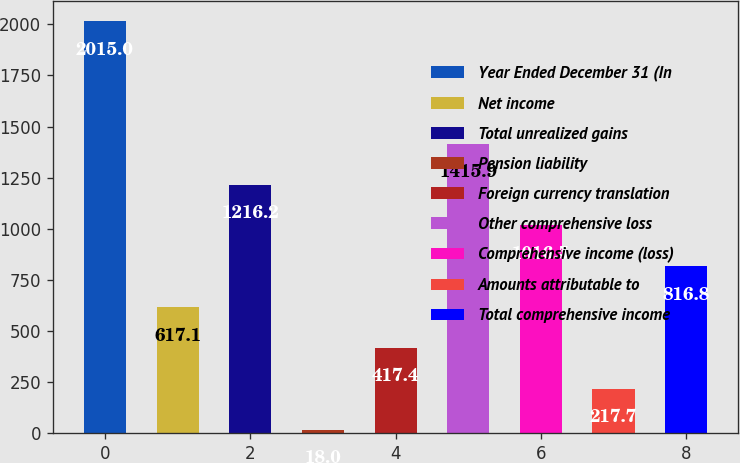Convert chart. <chart><loc_0><loc_0><loc_500><loc_500><bar_chart><fcel>Year Ended December 31 (In<fcel>Net income<fcel>Total unrealized gains<fcel>Pension liability<fcel>Foreign currency translation<fcel>Other comprehensive loss<fcel>Comprehensive income (loss)<fcel>Amounts attributable to<fcel>Total comprehensive income<nl><fcel>2015<fcel>617.1<fcel>1216.2<fcel>18<fcel>417.4<fcel>1415.9<fcel>1016.5<fcel>217.7<fcel>816.8<nl></chart> 